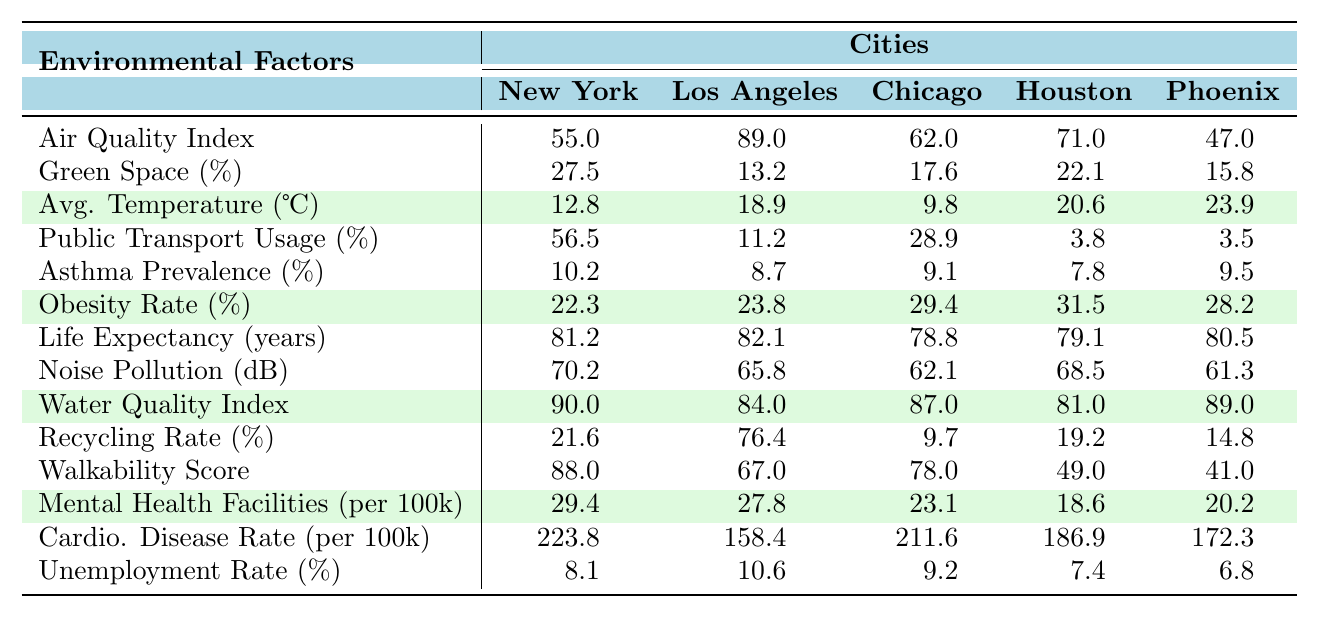What is the air quality index for Chicago? According to the table, the air quality index is listed directly next to Chicago, which shows a value of 62.0.
Answer: 62.0 Which city has the highest green space percentage? By comparing the green space percentages across the cities, New York City has the highest value at 27.5.
Answer: New York City What is the average life expectancy across all the cities? To find the average life expectancy, add all the values: (81.2 + 82.1 + 78.8 + 79.1 + 80.5) = 401.7. Then divide by the number of cities (5): 401.7 / 5 = 80.34.
Answer: 80.34 Is the asthma prevalence percentage higher in Houston than in Phoenix? The asthma prevalence percentage for Houston is 7.8 and for Phoenix is 9.5. Since 7.8 is less than 9.5, it is not higher in Houston.
Answer: No Which city has the lowest obesity rate percentage? By examining the obesity rates, Houston has the lowest value at 31.5.
Answer: Houston How much higher is the public transportation usage percentage in New York City compared to Los Angeles? The public transportation usage percentage in New York City is 56.5, and in Los Angeles, it is 11.2. Subtracting the two gives: 56.5 - 11.2 = 45.3, indicating it is 45.3% higher in New York City.
Answer: 45.3% Which city has the lowest noise pollution level? From the table, Phoenix has the lowest noise pollution level at 61.3 dB as compared to others.
Answer: Phoenix What is the correlation between average temperature and asthma prevalence based on visual inspection? Visually analyzing the data, cities with higher average temperatures (Houston and Phoenix) have lower asthma prevalence percentages compared to cooler cities (New York and Chicago), suggesting a potential inverse correlation.
Answer: Inverse correlation (not definitive) If the unemployment rate in Los Angeles decreased to 8%, how would it compare to the average unemployment rate of these cities? The current unemployment rates sum to (8.1 + 10.6 + 9.2 + 7.4 + 8) = 43.3 and dividing by 5 gives an average of 8.66. Therefore, with Los Angeles' new rate of 8%, it would be lower than the average.
Answer: Lower than average What city has the highest recycling rate percentage? From the data, Los Angeles has a recycling rate of 76.4, which is the highest among the listed cities.
Answer: Los Angeles 